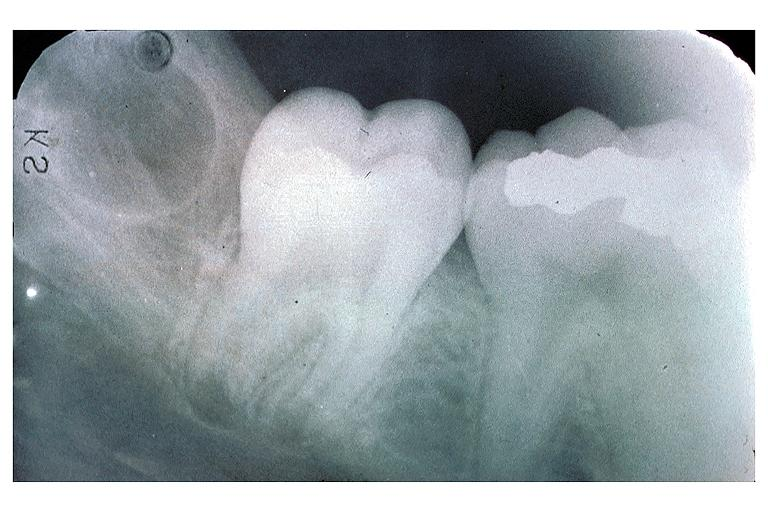does liver show developing 3rd molar?
Answer the question using a single word or phrase. No 